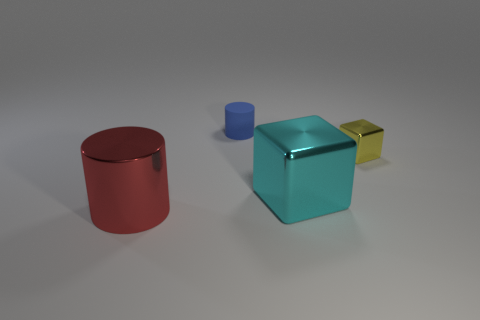Is there anything else that is made of the same material as the small blue cylinder?
Ensure brevity in your answer.  No. What is the shape of the yellow object?
Provide a succinct answer. Cube. What number of other large metal objects have the same shape as the cyan thing?
Your response must be concise. 0. Are there fewer tiny blue objects on the right side of the big cyan shiny object than big cyan things on the left side of the matte object?
Your answer should be compact. No. How many cubes are to the left of the big metal object that is in front of the large cyan metal cube?
Ensure brevity in your answer.  0. Are any yellow blocks visible?
Provide a succinct answer. Yes. Are there any tiny purple cylinders that have the same material as the red cylinder?
Your answer should be compact. No. Are there more big red objects on the right side of the big red cylinder than objects that are on the left side of the blue cylinder?
Your answer should be very brief. No. Does the rubber cylinder have the same size as the cyan shiny object?
Provide a short and direct response. No. The metal cube to the right of the big thing that is behind the red metallic thing is what color?
Provide a succinct answer. Yellow. 